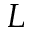Convert formula to latex. <formula><loc_0><loc_0><loc_500><loc_500>L</formula> 